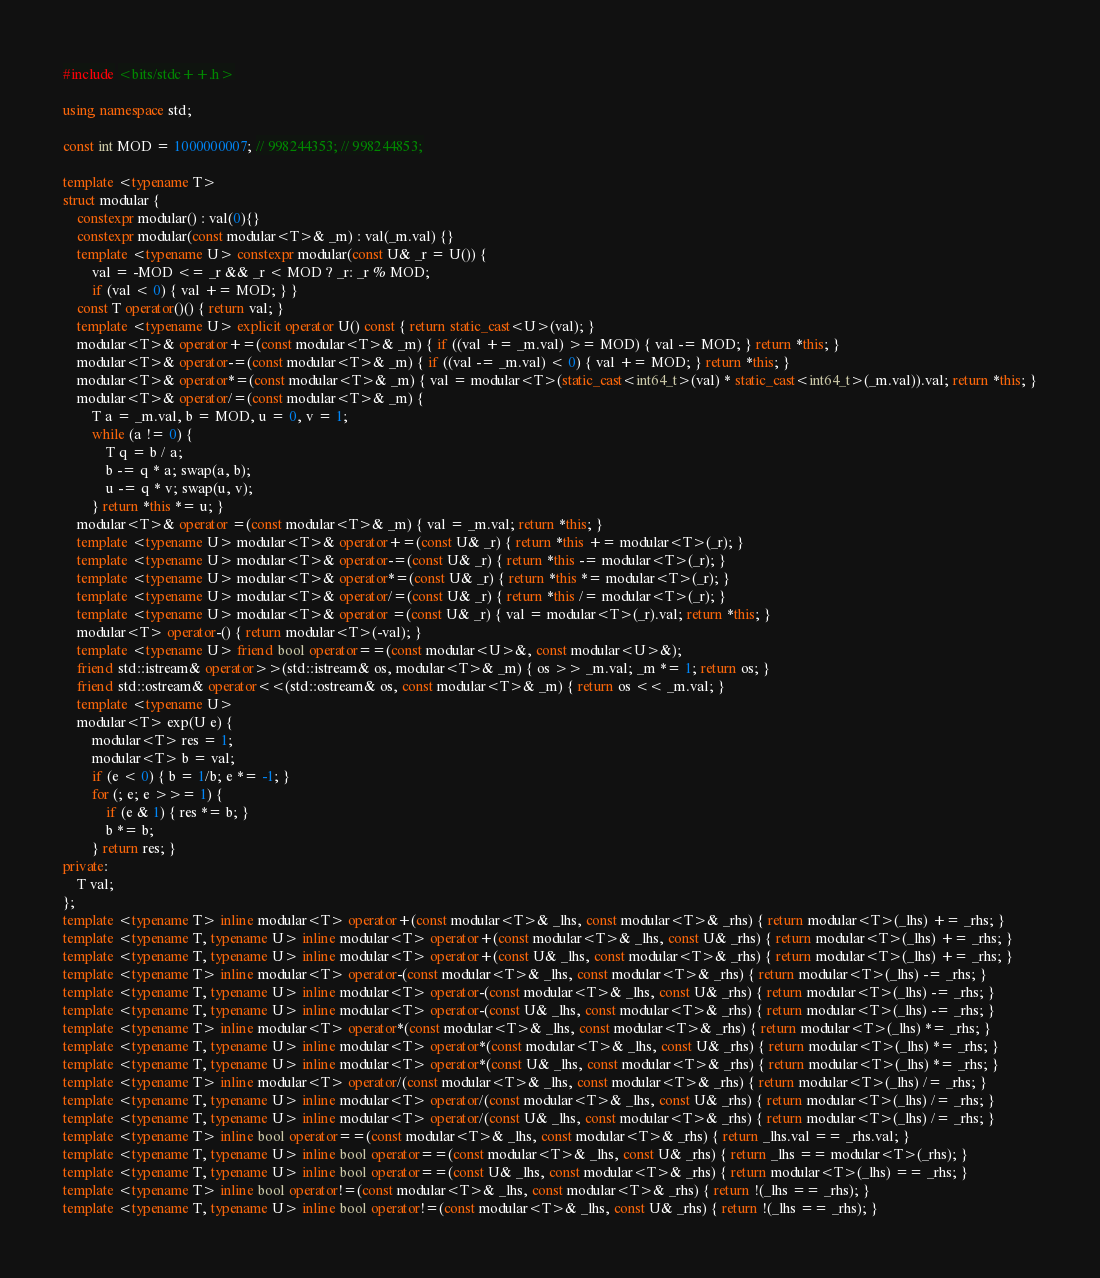<code> <loc_0><loc_0><loc_500><loc_500><_C++_>#include <bits/stdc++.h>

using namespace std;

const int MOD = 1000000007; // 998244353; // 998244853;

template <typename T>
struct modular {
    constexpr modular() : val(0){}
    constexpr modular(const modular<T>& _m) : val(_m.val) {}
    template <typename U> constexpr modular(const U& _r = U()) {
        val = -MOD <= _r && _r < MOD ? _r: _r % MOD;
        if (val < 0) { val += MOD; } }
    const T operator()() { return val; }
    template <typename U> explicit operator U() const { return static_cast<U>(val); }
    modular<T>& operator+=(const modular<T>& _m) { if ((val += _m.val) >= MOD) { val -= MOD; } return *this; }
    modular<T>& operator-=(const modular<T>& _m) { if ((val -= _m.val) < 0) { val += MOD; } return *this; }
    modular<T>& operator*=(const modular<T>& _m) { val = modular<T>(static_cast<int64_t>(val) * static_cast<int64_t>(_m.val)).val; return *this; }
    modular<T>& operator/=(const modular<T>& _m) {
        T a = _m.val, b = MOD, u = 0, v = 1;
        while (a != 0) {
            T q = b / a;
            b -= q * a; swap(a, b);
            u -= q * v; swap(u, v); 
        } return *this *= u; }
    modular<T>& operator =(const modular<T>& _m) { val = _m.val; return *this; }
    template <typename U> modular<T>& operator+=(const U& _r) { return *this += modular<T>(_r); }
    template <typename U> modular<T>& operator-=(const U& _r) { return *this -= modular<T>(_r); }
    template <typename U> modular<T>& operator*=(const U& _r) { return *this *= modular<T>(_r); }
    template <typename U> modular<T>& operator/=(const U& _r) { return *this /= modular<T>(_r); } 
    template <typename U> modular<T>& operator =(const U& _r) { val = modular<T>(_r).val; return *this; }
    modular<T> operator-() { return modular<T>(-val); }    
    template <typename U> friend bool operator==(const modular<U>&, const modular<U>&);
    friend std::istream& operator>>(std::istream& os, modular<T>& _m) { os >> _m.val; _m *= 1; return os; }
    friend std::ostream& operator<<(std::ostream& os, const modular<T>& _m) { return os << _m.val; }
    template <typename U>
    modular<T> exp(U e) {
        modular<T> res = 1;
        modular<T> b = val;
        if (e < 0) { b = 1/b; e *= -1; }
        for (; e; e >>= 1) {
            if (e & 1) { res *= b; }
            b *= b;
        } return res; }
private:
    T val;
};
template <typename T> inline modular<T> operator+(const modular<T>& _lhs, const modular<T>& _rhs) { return modular<T>(_lhs) += _rhs; }
template <typename T, typename U> inline modular<T> operator+(const modular<T>& _lhs, const U& _rhs) { return modular<T>(_lhs) += _rhs; }
template <typename T, typename U> inline modular<T> operator+(const U& _lhs, const modular<T>& _rhs) { return modular<T>(_lhs) += _rhs; }
template <typename T> inline modular<T> operator-(const modular<T>& _lhs, const modular<T>& _rhs) { return modular<T>(_lhs) -= _rhs; }
template <typename T, typename U> inline modular<T> operator-(const modular<T>& _lhs, const U& _rhs) { return modular<T>(_lhs) -= _rhs; }
template <typename T, typename U> inline modular<T> operator-(const U& _lhs, const modular<T>& _rhs) { return modular<T>(_lhs) -= _rhs; }
template <typename T> inline modular<T> operator*(const modular<T>& _lhs, const modular<T>& _rhs) { return modular<T>(_lhs) *= _rhs; }
template <typename T, typename U> inline modular<T> operator*(const modular<T>& _lhs, const U& _rhs) { return modular<T>(_lhs) *= _rhs; }
template <typename T, typename U> inline modular<T> operator*(const U& _lhs, const modular<T>& _rhs) { return modular<T>(_lhs) *= _rhs; }
template <typename T> inline modular<T> operator/(const modular<T>& _lhs, const modular<T>& _rhs) { return modular<T>(_lhs) /= _rhs; }
template <typename T, typename U> inline modular<T> operator/(const modular<T>& _lhs, const U& _rhs) { return modular<T>(_lhs) /= _rhs; }
template <typename T, typename U> inline modular<T> operator/(const U& _lhs, const modular<T>& _rhs) { return modular<T>(_lhs) /= _rhs; }
template <typename T> inline bool operator==(const modular<T>& _lhs, const modular<T>& _rhs) { return _lhs.val == _rhs.val; }
template <typename T, typename U> inline bool operator==(const modular<T>& _lhs, const U& _rhs) { return _lhs == modular<T>(_rhs); }
template <typename T, typename U> inline bool operator==(const U& _lhs, const modular<T>& _rhs) { return modular<T>(_lhs) == _rhs; }
template <typename T> inline bool operator!=(const modular<T>& _lhs, const modular<T>& _rhs) { return !(_lhs == _rhs); }
template <typename T, typename U> inline bool operator!=(const modular<T>& _lhs, const U& _rhs) { return !(_lhs == _rhs); }</code> 